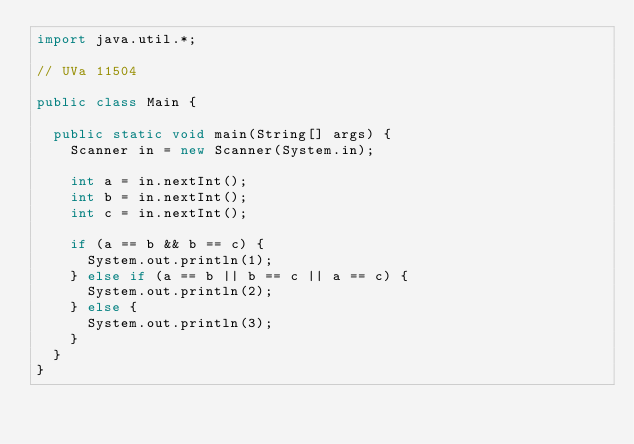<code> <loc_0><loc_0><loc_500><loc_500><_Java_>import java.util.*;

// UVa 11504

public class Main {

	public static void main(String[] args) {
		Scanner in = new Scanner(System.in);
		
		int a = in.nextInt();
		int b = in.nextInt();
		int c = in.nextInt();
		
		if (a == b && b == c) {
			System.out.println(1);
		} else if (a == b || b == c || a == c) {
			System.out.println(2);
		} else {
			System.out.println(3);
		}
	}
}</code> 